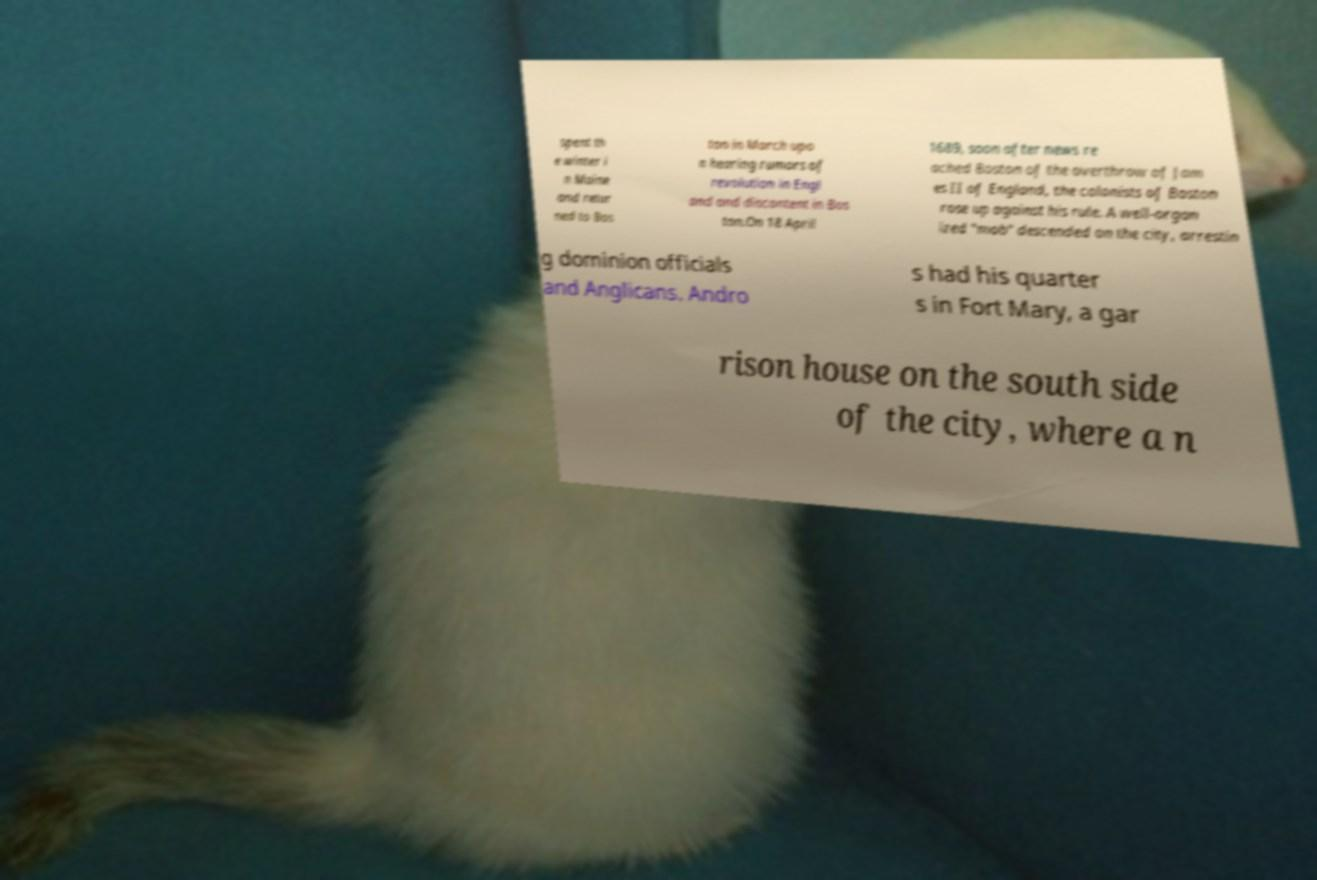There's text embedded in this image that I need extracted. Can you transcribe it verbatim? spent th e winter i n Maine and retur ned to Bos ton in March upo n hearing rumors of revolution in Engl and and discontent in Bos ton.On 18 April 1689, soon after news re ached Boston of the overthrow of Jam es II of England, the colonists of Boston rose up against his rule. A well-organ ized "mob" descended on the city, arrestin g dominion officials and Anglicans. Andro s had his quarter s in Fort Mary, a gar rison house on the south side of the city, where a n 